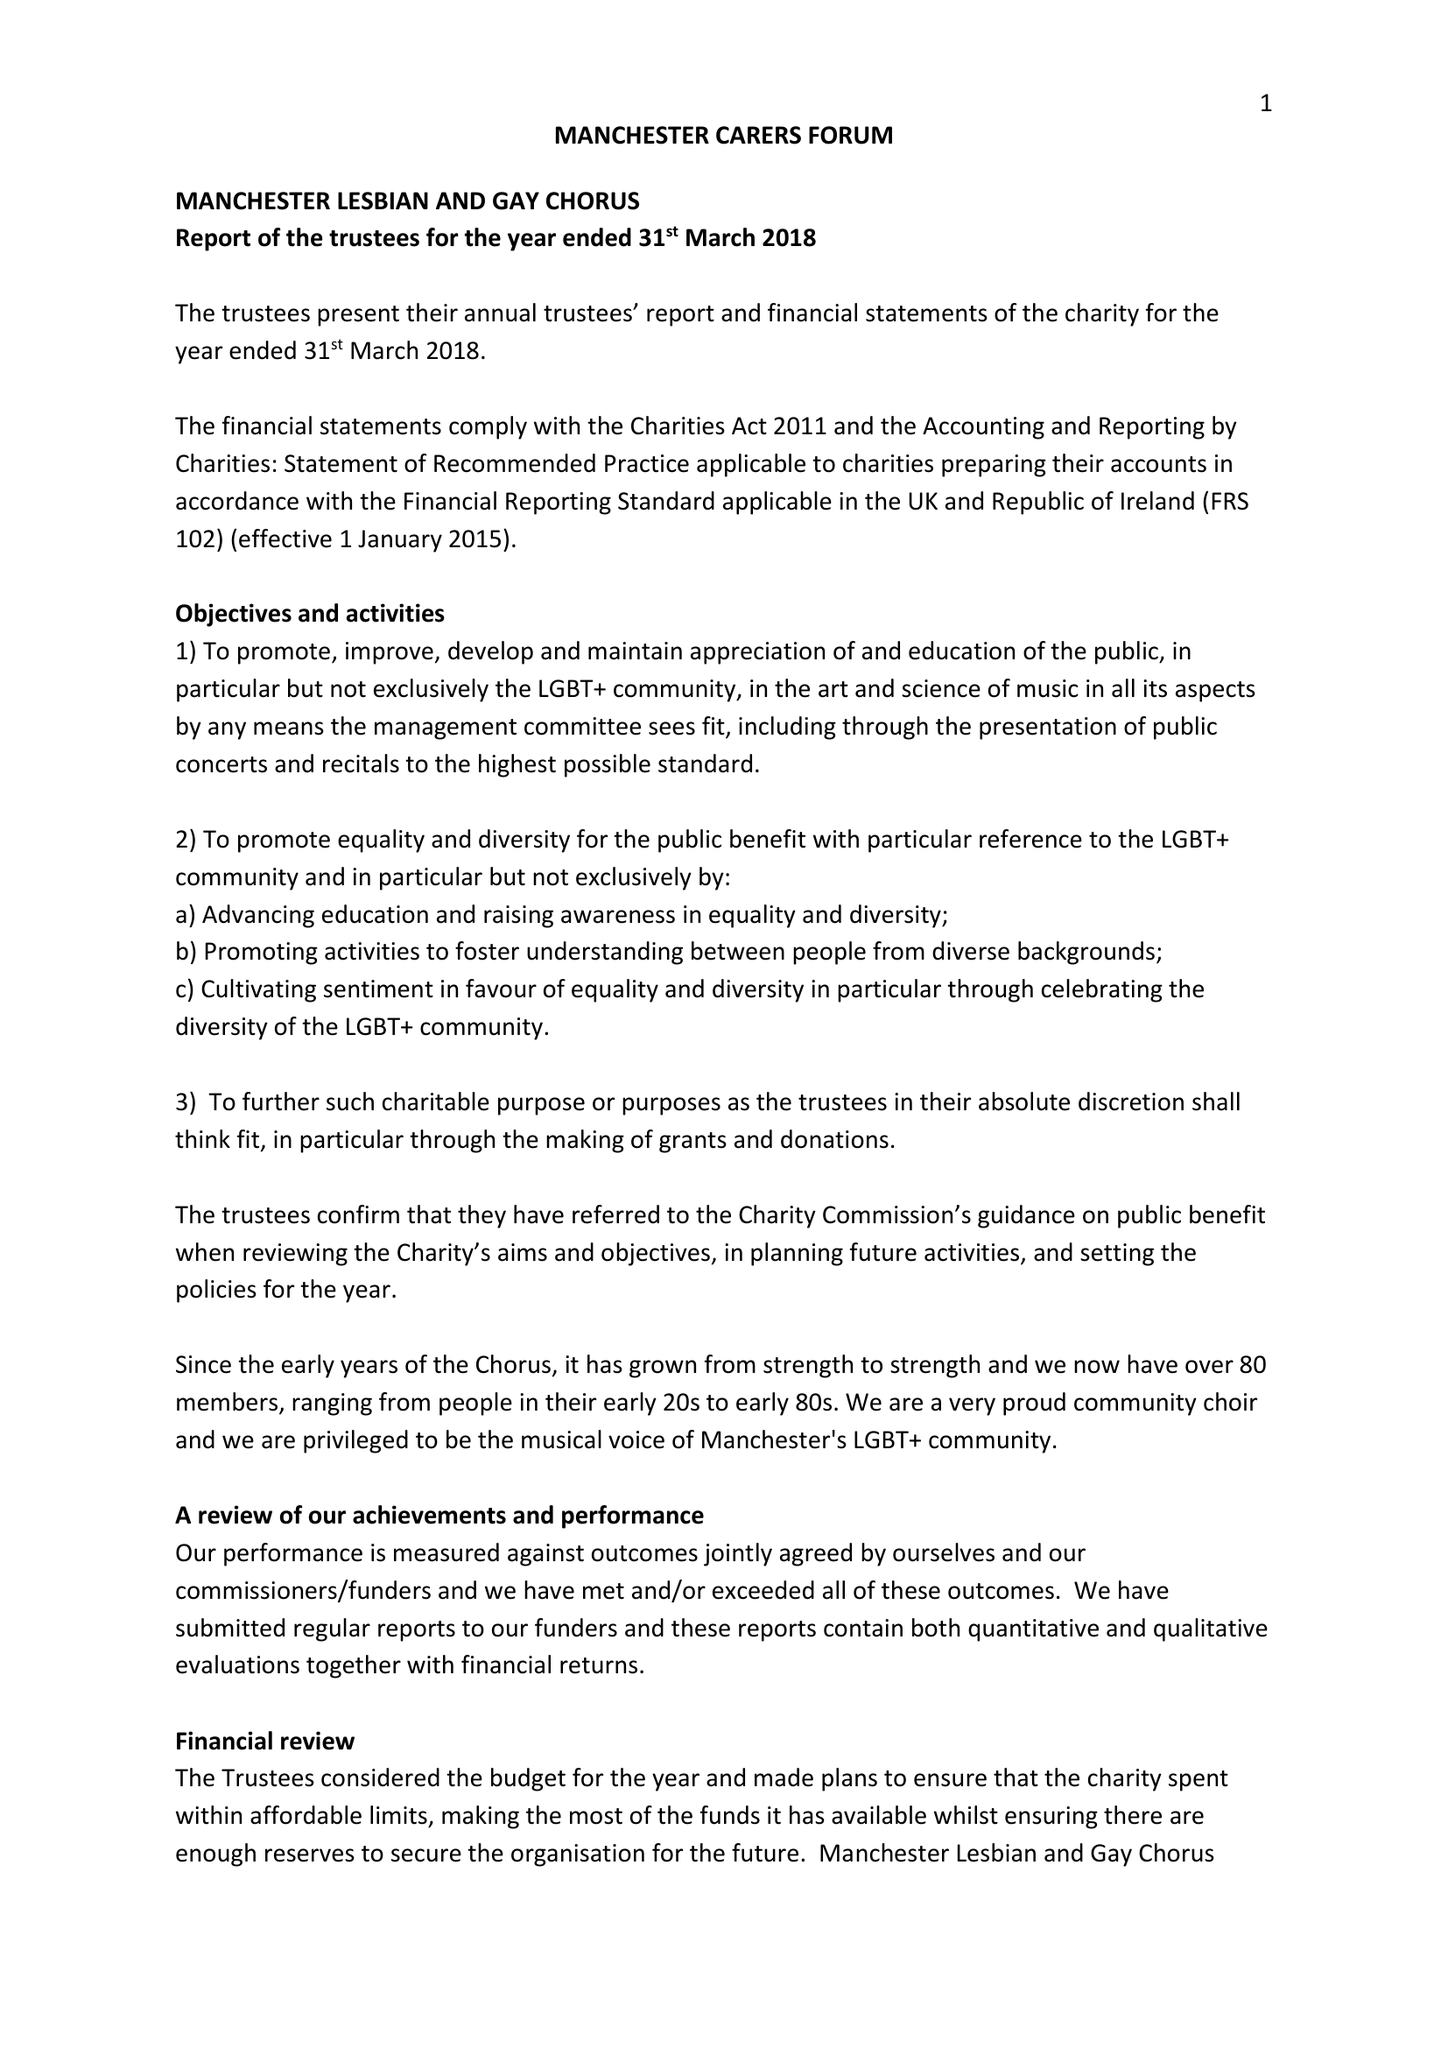What is the value for the report_date?
Answer the question using a single word or phrase. 2018-03-31 